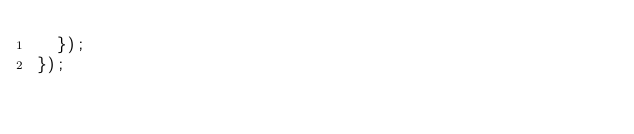<code> <loc_0><loc_0><loc_500><loc_500><_TypeScript_>  });
});
</code> 